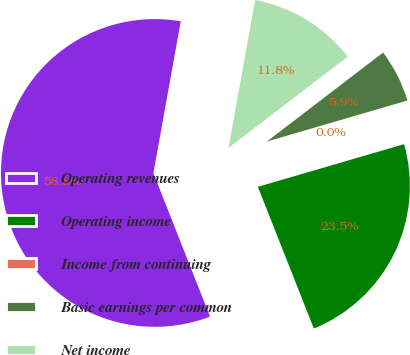Convert chart to OTSL. <chart><loc_0><loc_0><loc_500><loc_500><pie_chart><fcel>Operating revenues<fcel>Operating income<fcel>Income from continuing<fcel>Basic earnings per common<fcel>Net income<nl><fcel>58.82%<fcel>23.53%<fcel>0.0%<fcel>5.88%<fcel>11.76%<nl></chart> 